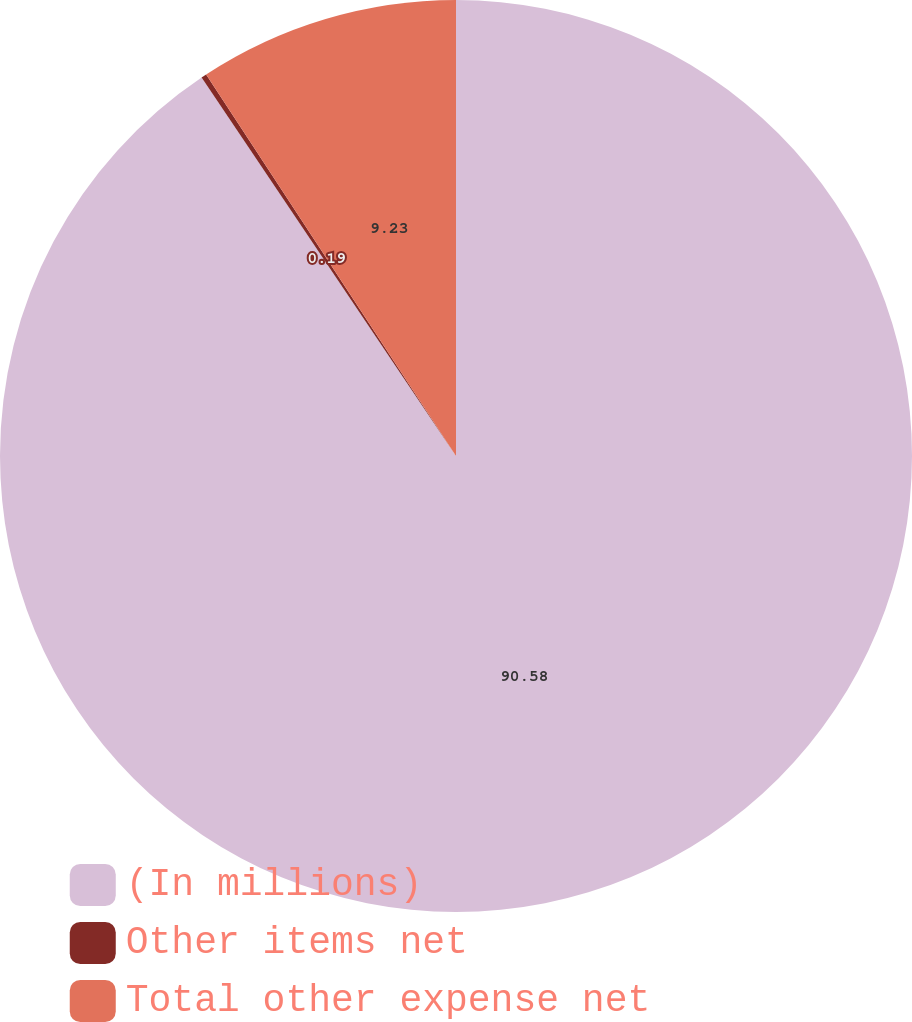Convert chart to OTSL. <chart><loc_0><loc_0><loc_500><loc_500><pie_chart><fcel>(In millions)<fcel>Other items net<fcel>Total other expense net<nl><fcel>90.58%<fcel>0.19%<fcel>9.23%<nl></chart> 